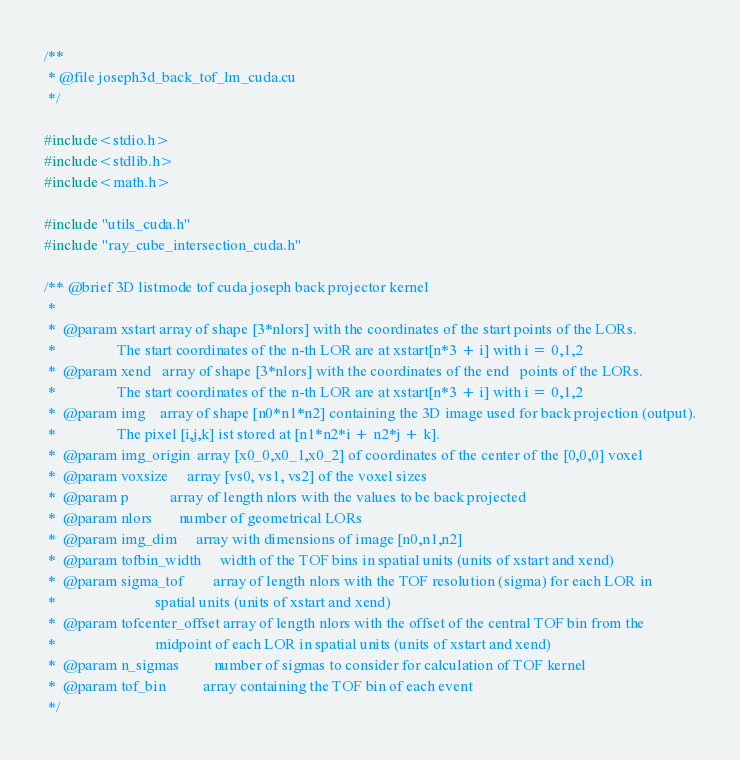<code> <loc_0><loc_0><loc_500><loc_500><_Cuda_>/**
 * @file joseph3d_back_tof_lm_cuda.cu
 */

#include<stdio.h>
#include<stdlib.h>
#include<math.h>

#include "utils_cuda.h"
#include "ray_cube_intersection_cuda.h"

/** @brief 3D listmode tof cuda joseph back projector kernel
 *
 *  @param xstart array of shape [3*nlors] with the coordinates of the start points of the LORs.
 *                The start coordinates of the n-th LOR are at xstart[n*3 + i] with i = 0,1,2 
 *  @param xend   array of shape [3*nlors] with the coordinates of the end   points of the LORs.
 *                The start coordinates of the n-th LOR are at xstart[n*3 + i] with i = 0,1,2 
 *  @param img    array of shape [n0*n1*n2] containing the 3D image used for back projection (output).
 *                The pixel [i,j,k] ist stored at [n1*n2*i + n2*j + k].
 *  @param img_origin  array [x0_0,x0_1,x0_2] of coordinates of the center of the [0,0,0] voxel
 *  @param voxsize     array [vs0, vs1, vs2] of the voxel sizes
 *  @param p           array of length nlors with the values to be back projected
 *  @param nlors       number of geometrical LORs
 *  @param img_dim     array with dimensions of image [n0,n1,n2]
 *  @param tofbin_width     width of the TOF bins in spatial units (units of xstart and xend)
 *  @param sigma_tof        array of length nlors with the TOF resolution (sigma) for each LOR in
 *                          spatial units (units of xstart and xend) 
 *  @param tofcenter_offset array of length nlors with the offset of the central TOF bin from the 
 *                          midpoint of each LOR in spatial units (units of xstart and xend) 
 *  @param n_sigmas         number of sigmas to consider for calculation of TOF kernel
 *  @param tof_bin          array containing the TOF bin of each event
 */</code> 